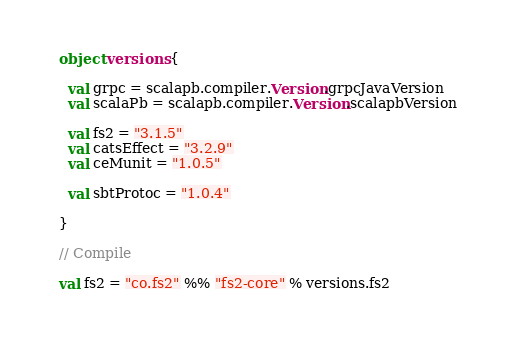<code> <loc_0><loc_0><loc_500><loc_500><_Scala_>
  object versions {

    val grpc = scalapb.compiler.Version.grpcJavaVersion
    val scalaPb = scalapb.compiler.Version.scalapbVersion

    val fs2 = "3.1.5"
    val catsEffect = "3.2.9"
    val ceMunit = "1.0.5"

    val sbtProtoc = "1.0.4"

  }

  // Compile

  val fs2 = "co.fs2" %% "fs2-core" % versions.fs2</code> 